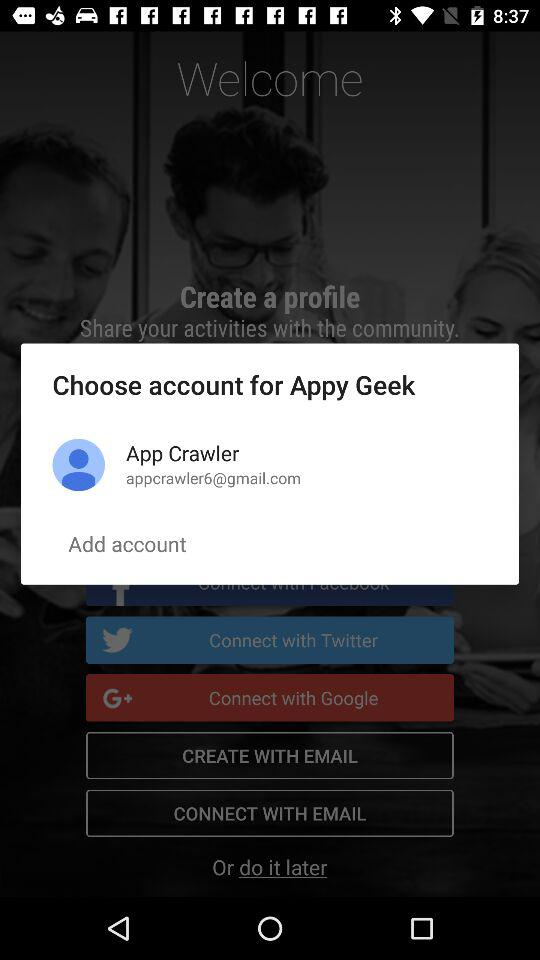What is the contact number for App Crawler?
When the provided information is insufficient, respond with <no answer>. <no answer> 